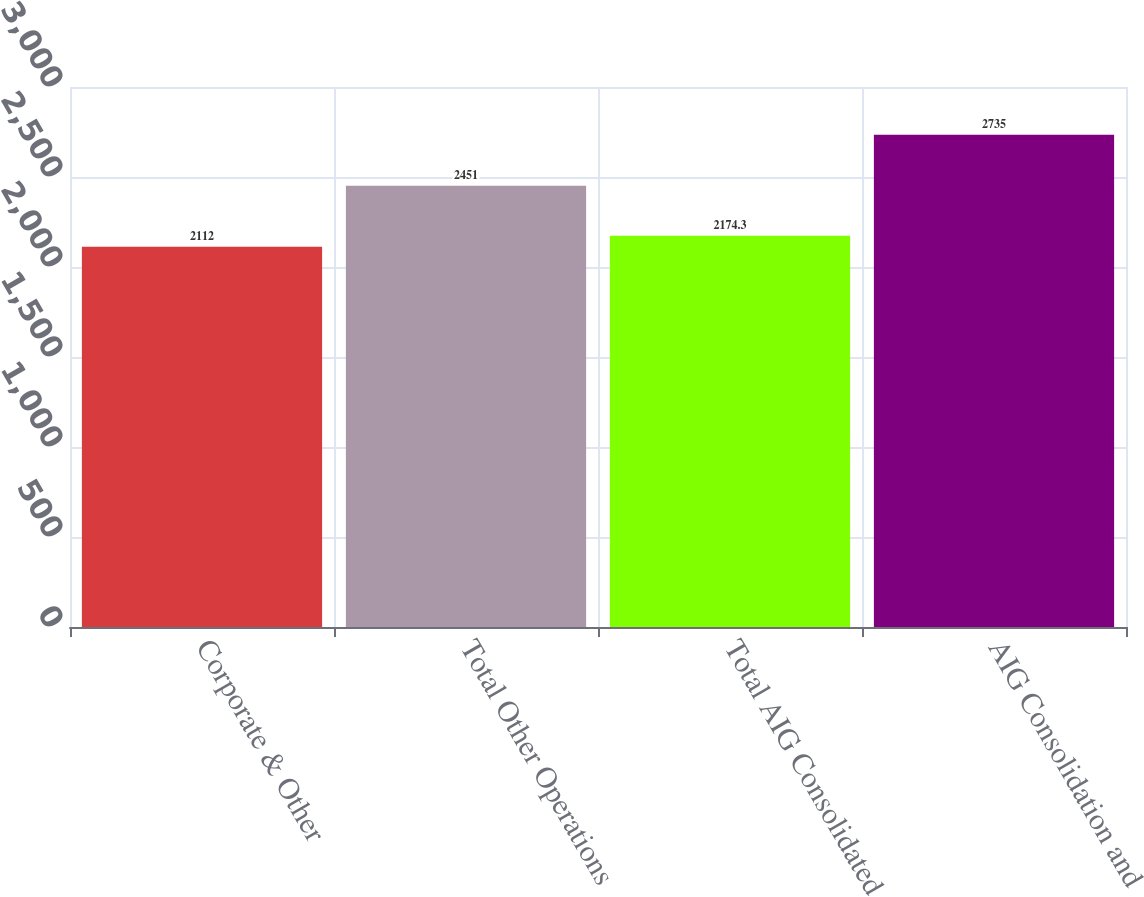Convert chart. <chart><loc_0><loc_0><loc_500><loc_500><bar_chart><fcel>Corporate & Other<fcel>Total Other Operations<fcel>Total AIG Consolidated<fcel>AIG Consolidation and<nl><fcel>2112<fcel>2451<fcel>2174.3<fcel>2735<nl></chart> 